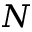<formula> <loc_0><loc_0><loc_500><loc_500>N</formula> 